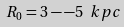<formula> <loc_0><loc_0><loc_500><loc_500>R _ { 0 } = 3 - - 5 \ k p c</formula> 